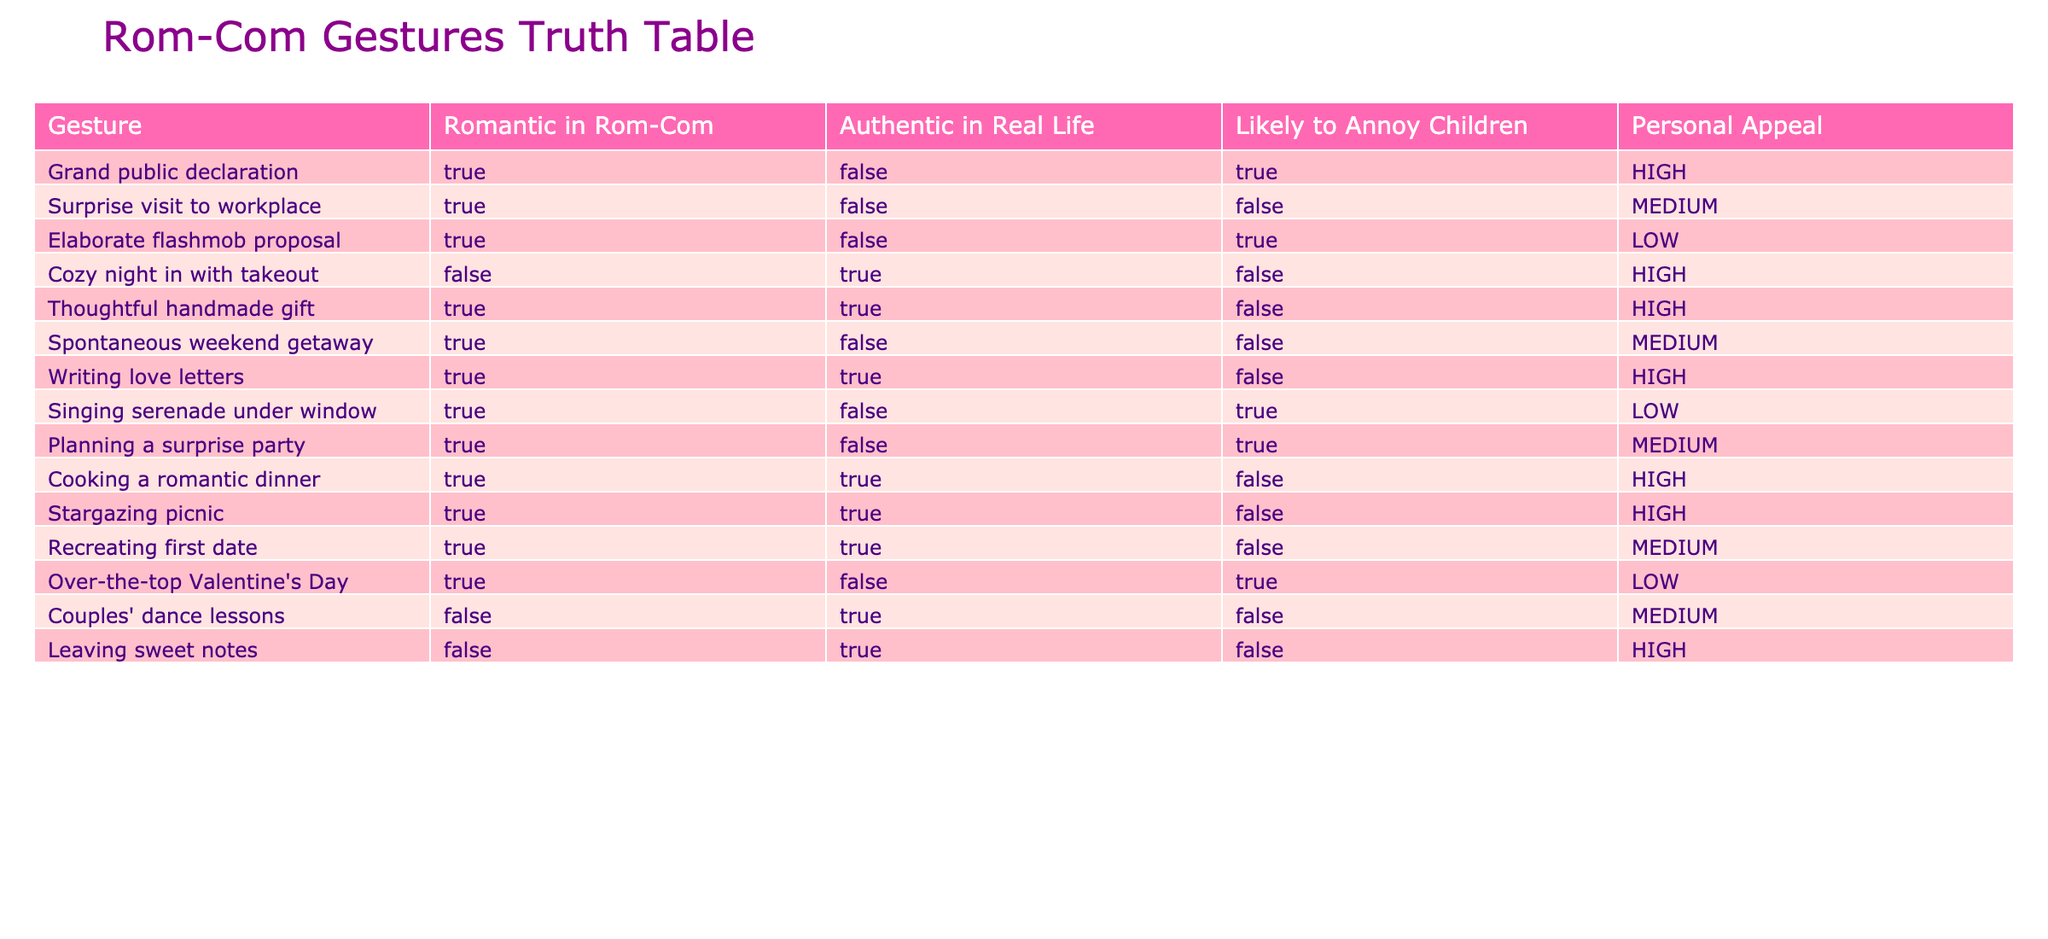What gestures are considered romantic in rom-coms but not authentic in real life? Looking at the table, we can see that the gestures "Grand public declaration," "Surprise visit to workplace," "Elaborate flashmob proposal," "Singing serenade under window," "Planning a surprise party," and "Over-the-top Valentine's Day" are marked as romantic in rom-coms (TRUE) but not authentic in real life (FALSE).
Answer: Six gestures What is the personal appeal rating for a cozy night in with takeout? The personal appeal for "Cozy night in with takeout" is listed as HIGH in the table. This can be found in the "Personal Appeal" column for that specific gesture.
Answer: HIGH Are thoughtful handmade gifts authentic in real life according to the table? The table indicates that "Thoughtful handmade gift" is marked as authentic in real life (TRUE), meaning this gesture is generally viewed as genuine outside of films.
Answer: Yes Which romantic gesture likely annoys children the most? The "Grand public declaration," "Elaborate flashmob proposal," "Singing serenade under window," and "Planning a surprise party" are all marked as likely to annoy children (TRUE). Among these, the "Grand public declaration" is listed first in the table. Thus, it can be interpreted as a gesture most likely to annoy children.
Answer: Grand public declaration What is the total number of gestures rated as authentic in real life? By examining the table, the gestures that are authentic in real life (TRUE) are "Cozy night in with takeout," "Thoughtful handmade gift," "Writing love letters," "Cooking a romantic dinner," "Stargazing picnic," and "Recreating first date." Counting these gives a total of six gestures.
Answer: Six gestures Are there any gestures that are romantic in rom-coms, authentic in real life, and have a high personal appeal? The table identifies "Thoughtful handmade gift," "Writing love letters," "Cooking a romantic dinner," and "Stargazing picnic" as gestures that meet all these criteria. Each of these gestures is marked TRUE in both romantic and authentic columns and has a personal appeal rated as HIGH.
Answer: Four gestures What is the average likelihood of gestures annoying children for gestures that are romantic in rom-coms? First, identify the gestures that are romantic in rom-coms. The annoying likelihood (TRUE) for these is present in the gestures: "Grand public declaration," "Singing serenade under window," "Elaborate flashmob proposal," "Planning a surprise party," and "Over-the-top Valentine's Day." Out of these, four annoy (TRUE) while one does not (FALSE). The average likelihood of annoying children is thus calculated as 4/5 = 0.8 or 80%.
Answer: 80% Do surprise visits to the workplace generally have high personal appeal? The personal appeal rating for "Surprise visit to workplace" in the table is categorized as MEDIUM. It does not reach the HIGH appeal rating level. Therefore, it can be concluded that it does not generally have high personal appeal.
Answer: No 